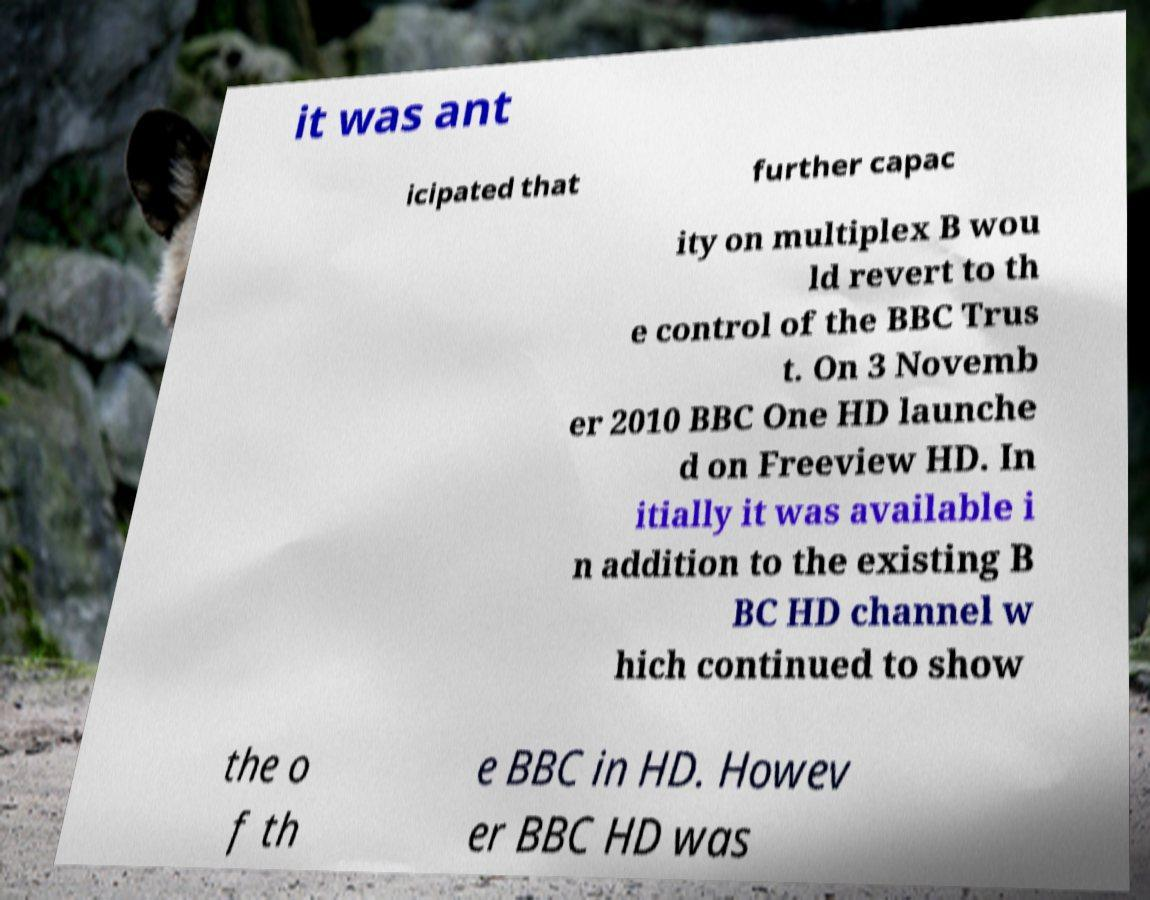Please identify and transcribe the text found in this image. it was ant icipated that further capac ity on multiplex B wou ld revert to th e control of the BBC Trus t. On 3 Novemb er 2010 BBC One HD launche d on Freeview HD. In itially it was available i n addition to the existing B BC HD channel w hich continued to show the o f th e BBC in HD. Howev er BBC HD was 